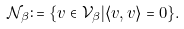Convert formula to latex. <formula><loc_0><loc_0><loc_500><loc_500>\mathcal { N } _ { \beta } \colon = \{ v \in \mathcal { V } _ { \beta } | \langle v , v \rangle = 0 \} .</formula> 